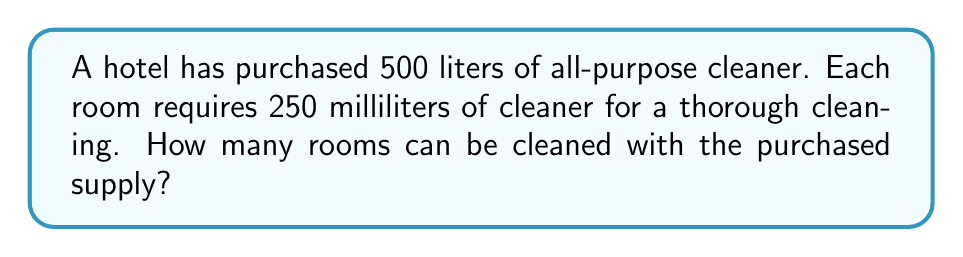Can you answer this question? To solve this problem, we need to follow these steps:

1. Convert liters to milliliters:
   $500 \text{ liters} = 500 \times 1000 = 500000 \text{ milliliters}$

2. Set up the division:
   $$\text{Number of rooms} = \frac{\text{Total cleaner available}}{\text{Cleaner needed per room}}$$

3. Plug in the values:
   $$\text{Number of rooms} = \frac{500000 \text{ mL}}{250 \text{ mL/room}}$$

4. Perform the division:
   $$\text{Number of rooms} = 2000$$

Therefore, 2000 rooms can be cleaned with the purchased supply of cleaner.
Answer: 2000 rooms 